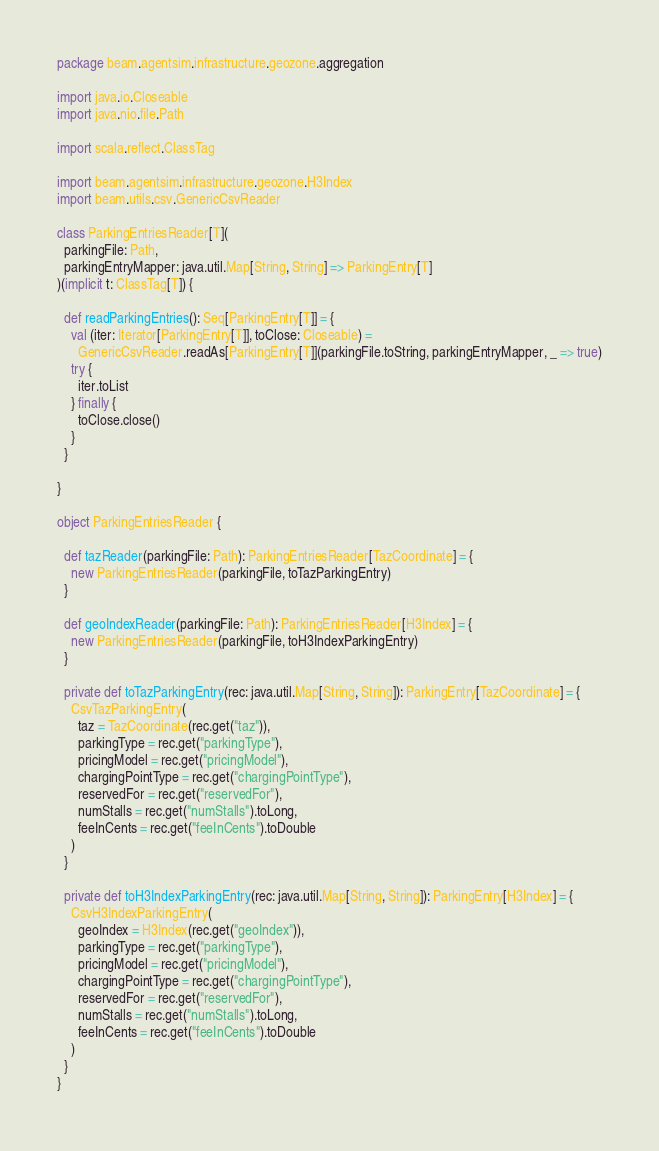Convert code to text. <code><loc_0><loc_0><loc_500><loc_500><_Scala_>package beam.agentsim.infrastructure.geozone.aggregation

import java.io.Closeable
import java.nio.file.Path

import scala.reflect.ClassTag

import beam.agentsim.infrastructure.geozone.H3Index
import beam.utils.csv.GenericCsvReader

class ParkingEntriesReader[T](
  parkingFile: Path,
  parkingEntryMapper: java.util.Map[String, String] => ParkingEntry[T]
)(implicit t: ClassTag[T]) {

  def readParkingEntries(): Seq[ParkingEntry[T]] = {
    val (iter: Iterator[ParkingEntry[T]], toClose: Closeable) =
      GenericCsvReader.readAs[ParkingEntry[T]](parkingFile.toString, parkingEntryMapper, _ => true)
    try {
      iter.toList
    } finally {
      toClose.close()
    }
  }

}

object ParkingEntriesReader {

  def tazReader(parkingFile: Path): ParkingEntriesReader[TazCoordinate] = {
    new ParkingEntriesReader(parkingFile, toTazParkingEntry)
  }

  def geoIndexReader(parkingFile: Path): ParkingEntriesReader[H3Index] = {
    new ParkingEntriesReader(parkingFile, toH3IndexParkingEntry)
  }

  private def toTazParkingEntry(rec: java.util.Map[String, String]): ParkingEntry[TazCoordinate] = {
    CsvTazParkingEntry(
      taz = TazCoordinate(rec.get("taz")),
      parkingType = rec.get("parkingType"),
      pricingModel = rec.get("pricingModel"),
      chargingPointType = rec.get("chargingPointType"),
      reservedFor = rec.get("reservedFor"),
      numStalls = rec.get("numStalls").toLong,
      feeInCents = rec.get("feeInCents").toDouble
    )
  }

  private def toH3IndexParkingEntry(rec: java.util.Map[String, String]): ParkingEntry[H3Index] = {
    CsvH3IndexParkingEntry(
      geoIndex = H3Index(rec.get("geoIndex")),
      parkingType = rec.get("parkingType"),
      pricingModel = rec.get("pricingModel"),
      chargingPointType = rec.get("chargingPointType"),
      reservedFor = rec.get("reservedFor"),
      numStalls = rec.get("numStalls").toLong,
      feeInCents = rec.get("feeInCents").toDouble
    )
  }
}
</code> 